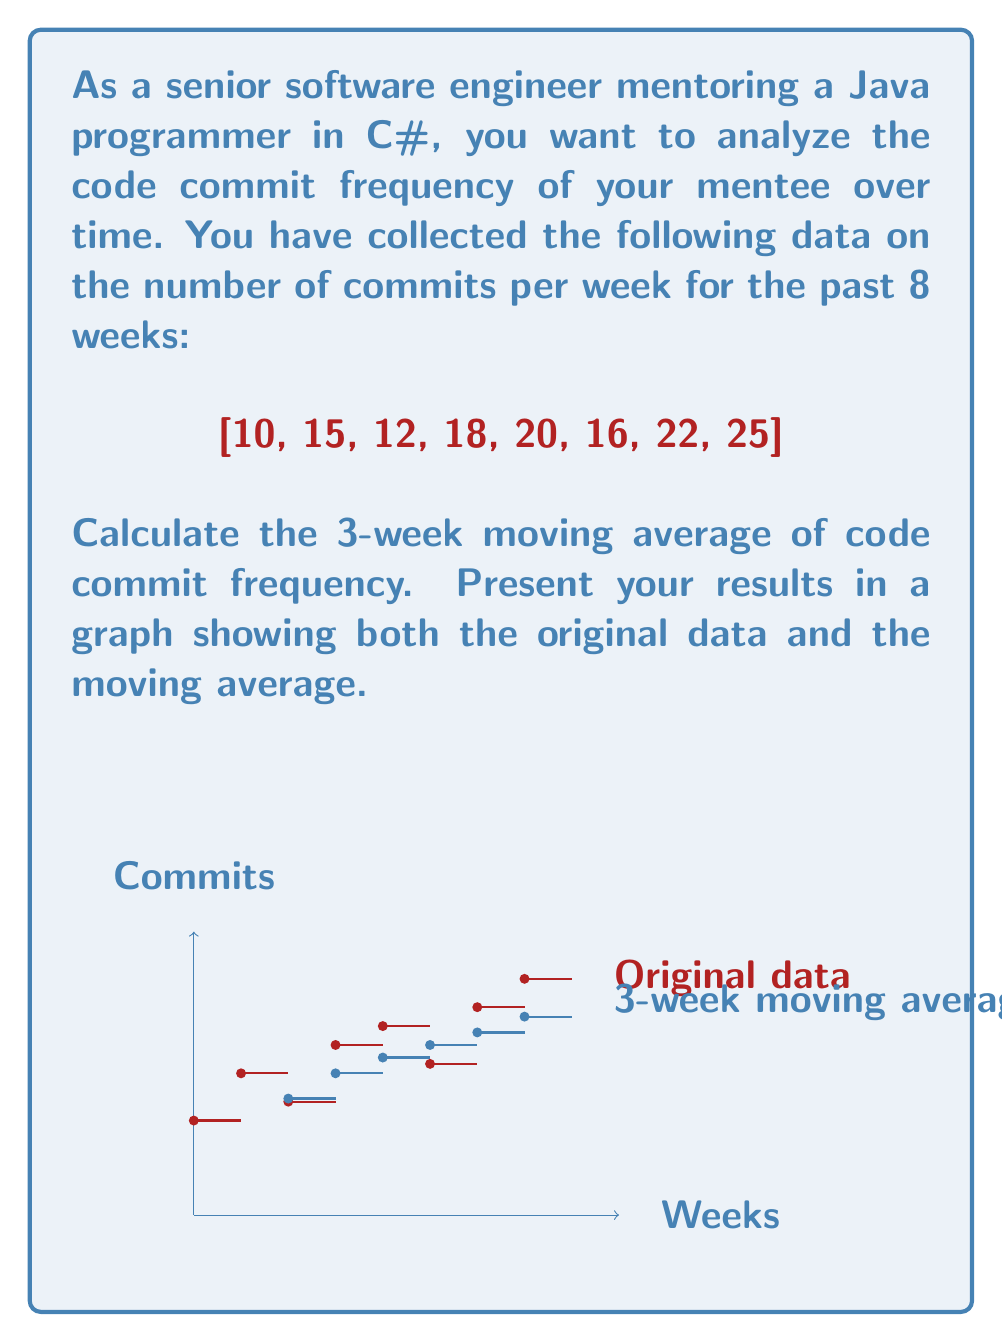Teach me how to tackle this problem. To calculate the 3-week moving average of code commit frequency, we need to follow these steps:

1) The formula for a simple moving average is:

   $$ \text{SMA}_t = \frac{1}{n} \sum_{i=t-n+1}^t x_i $$

   Where $\text{SMA}_t$ is the simple moving average at time t, n is the number of periods (in this case, 3), and $x_i$ are the individual values.

2) For a 3-week moving average, we start from the 3rd week:

   Week 3: $\text{SMA}_3 = \frac{10 + 15 + 12}{3} = 12.33$
   Week 4: $\text{SMA}_4 = \frac{15 + 12 + 18}{3} = 15$
   Week 5: $\text{SMA}_5 = \frac{12 + 18 + 20}{3} = 16.67$
   Week 6: $\text{SMA}_6 = \frac{18 + 20 + 16}{3} = 18$
   Week 7: $\text{SMA}_7 = \frac{20 + 16 + 22}{3} = 19.33$
   Week 8: $\text{SMA}_8 = \frac{16 + 22 + 25}{3} = 21$

3) The first two weeks don't have a 3-week moving average as there aren't enough previous data points.

4) The resulting 3-week moving average series is:

   [0, 0, 12.33, 15, 16.67, 18, 19.33, 21]

5) This series is plotted on the graph in blue, alongside the original data in red.

The moving average smooths out short-term fluctuations and shows the trend in commit frequency over time, which can be useful for tracking the mentee's progress in learning C#.
Answer: [0, 0, 12.33, 15, 16.67, 18, 19.33, 21] 